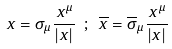<formula> <loc_0><loc_0><loc_500><loc_500>x = \sigma _ { \mu } \frac { \, x ^ { \mu } } { | x | } \ ; \ \overline { x } = \overline { \sigma } _ { \mu } \frac { \, x ^ { \mu } } { | x | } \,</formula> 